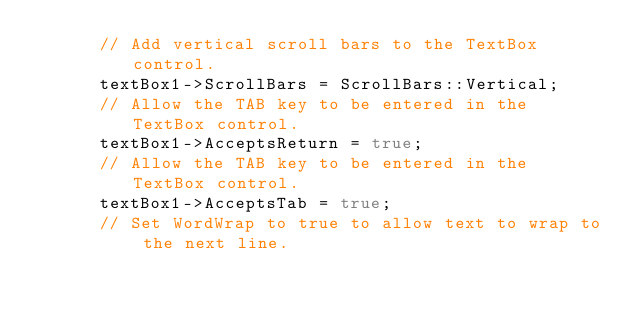Convert code to text. <code><loc_0><loc_0><loc_500><loc_500><_C++_>      // Add vertical scroll bars to the TextBox control.
      textBox1->ScrollBars = ScrollBars::Vertical;
      // Allow the TAB key to be entered in the TextBox control.
      textBox1->AcceptsReturn = true;
      // Allow the TAB key to be entered in the TextBox control.
      textBox1->AcceptsTab = true;
      // Set WordWrap to true to allow text to wrap to the next line.</code> 